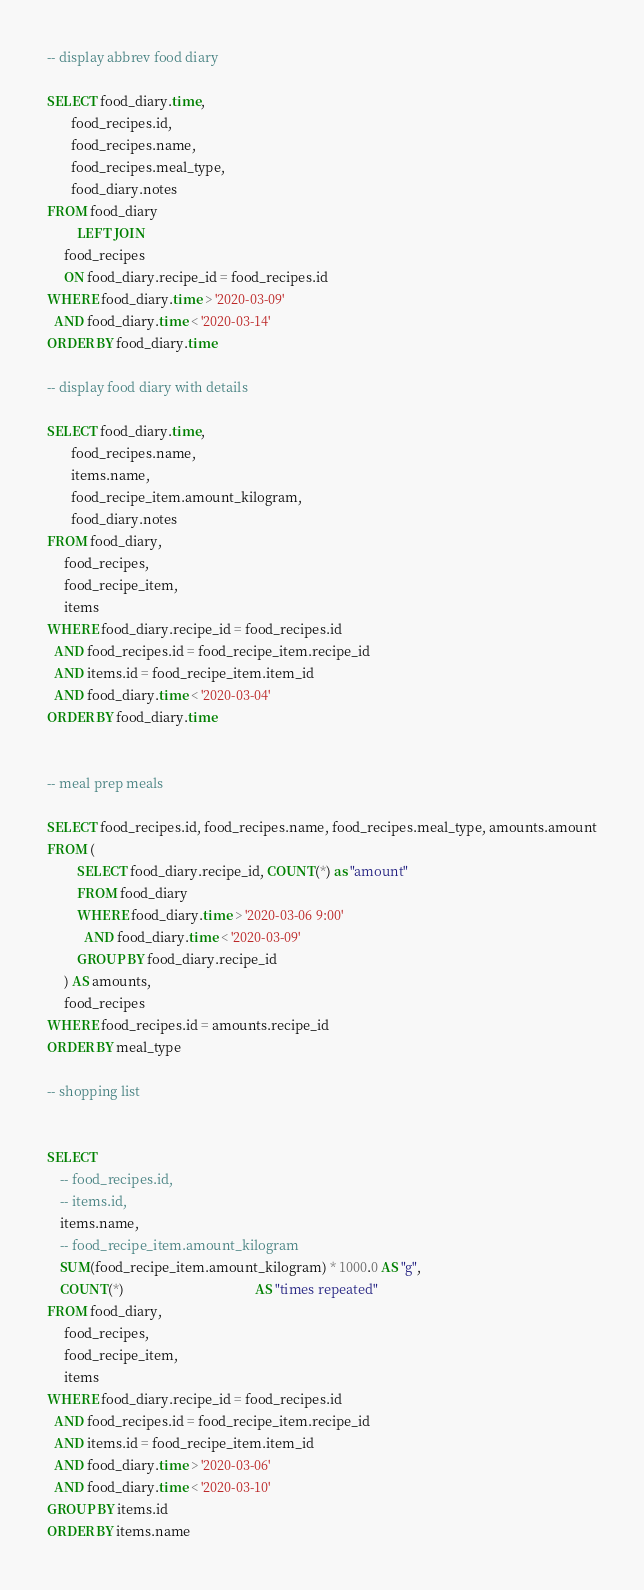<code> <loc_0><loc_0><loc_500><loc_500><_SQL_>-- display abbrev food diary

SELECT food_diary.time,
       food_recipes.id,
       food_recipes.name,
       food_recipes.meal_type,
       food_diary.notes
FROM food_diary
         LEFT JOIN
     food_recipes
     ON food_diary.recipe_id = food_recipes.id
WHERE food_diary.time > '2020-03-09'
  AND food_diary.time < '2020-03-14'
ORDER BY food_diary.time

-- display food diary with details

SELECT food_diary.time,
       food_recipes.name,
       items.name,
       food_recipe_item.amount_kilogram,
       food_diary.notes
FROM food_diary,
     food_recipes,
     food_recipe_item,
     items
WHERE food_diary.recipe_id = food_recipes.id
  AND food_recipes.id = food_recipe_item.recipe_id
  AND items.id = food_recipe_item.item_id
  AND food_diary.time < '2020-03-04'
ORDER BY food_diary.time


-- meal prep meals

SELECT food_recipes.id, food_recipes.name, food_recipes.meal_type, amounts.amount
FROM (
         SELECT food_diary.recipe_id, COUNT(*) as "amount"
         FROM food_diary
         WHERE food_diary.time > '2020-03-06 9:00'
           AND food_diary.time < '2020-03-09'
         GROUP BY food_diary.recipe_id
     ) AS amounts,
     food_recipes
WHERE food_recipes.id = amounts.recipe_id
ORDER BY meal_type

-- shopping list


SELECT
    -- food_recipes.id,
    -- items.id,
    items.name,
    -- food_recipe_item.amount_kilogram
    SUM(food_recipe_item.amount_kilogram) * 1000.0 AS "g",
    COUNT(*)                                       AS "times repeated"
FROM food_diary,
     food_recipes,
     food_recipe_item,
     items
WHERE food_diary.recipe_id = food_recipes.id
  AND food_recipes.id = food_recipe_item.recipe_id
  AND items.id = food_recipe_item.item_id
  AND food_diary.time > '2020-03-06'
  AND food_diary.time < '2020-03-10'
GROUP BY items.id
ORDER BY items.name
</code> 